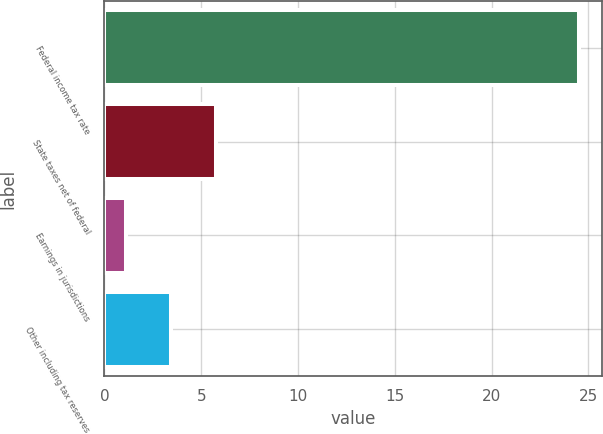Convert chart to OTSL. <chart><loc_0><loc_0><loc_500><loc_500><bar_chart><fcel>Federal income tax rate<fcel>State taxes net of federal<fcel>Earnings in jurisdictions<fcel>Other including tax reserves<nl><fcel>24.5<fcel>5.78<fcel>1.1<fcel>3.44<nl></chart> 